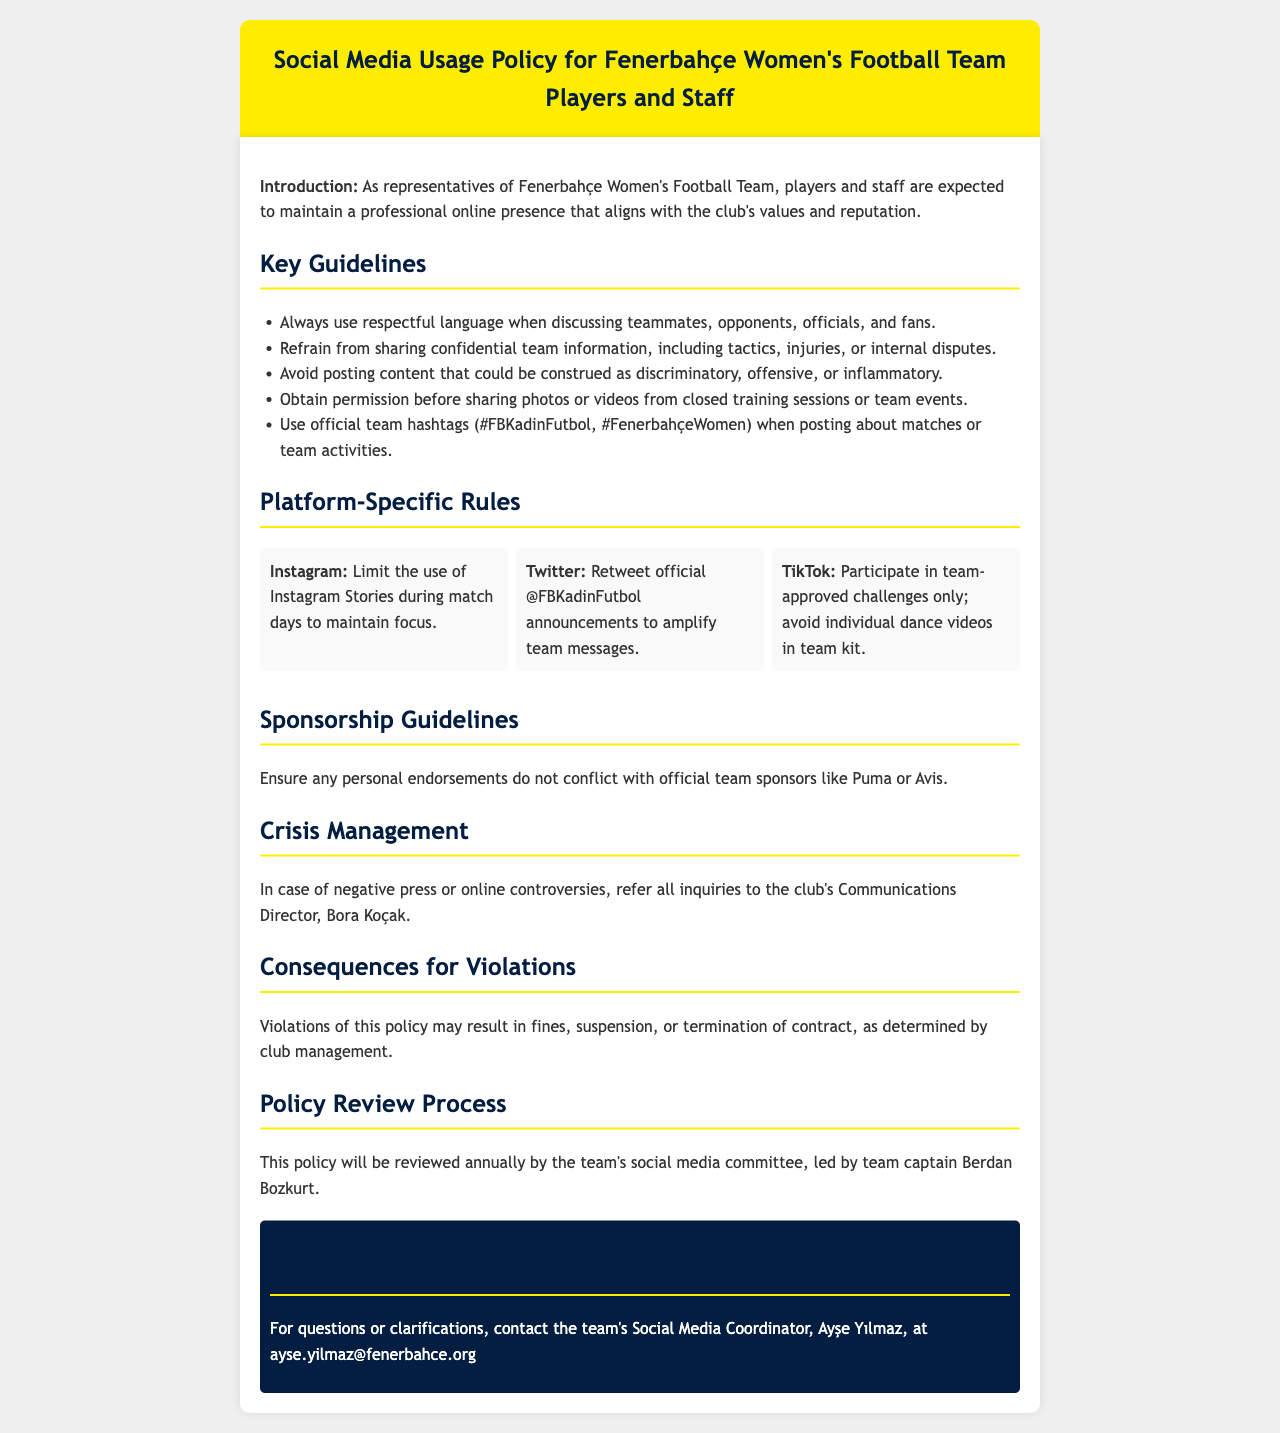What is the title of the document? The title is provided in the header of the document, which indicates the subject matter governing social media use.
Answer: Social Media Usage Policy for Fenerbahçe Women's Football Team Players and Staff Who is responsible for crisis management according to the document? The document specifies the person to refer to in case of negative press or online controversies, emphasizing their role in communication.
Answer: Bora Koçak What is the maximum number of platform-specific rules mentioned? The document contains specific rules for three different platforms, which are clearly detailed.
Answer: 3 What is the official team hashtag for Fenerbahçe Women's Football Team? The document lists the official hashtags that players and staff should use when posting about team activities.
Answer: #FBKadinFutbol, #FenerbahçeWomen What may happen if someone violates the social media policy? The document outlines the potential consequences of violating the policy, indicating punitive measures taken by the club.
Answer: fines, suspension, or termination of contract Who leads the policy review process? The document mentions the person responsible for overseeing the annual review of the social media policy, highlighting their leadership role.
Answer: Berdan Bozkurt What is the email address for the team's Social Media Coordinator? The document provides contact information for the Social Media Coordinator, ensuring players and staff know where to direct inquiries.
Answer: ayse.yilmaz@fenerbahce.org Which platform requires players to limit Stories during match days? The document specifies guidelines for handling social media interactions during matches, emphasizing focus on gameplay.
Answer: Instagram 